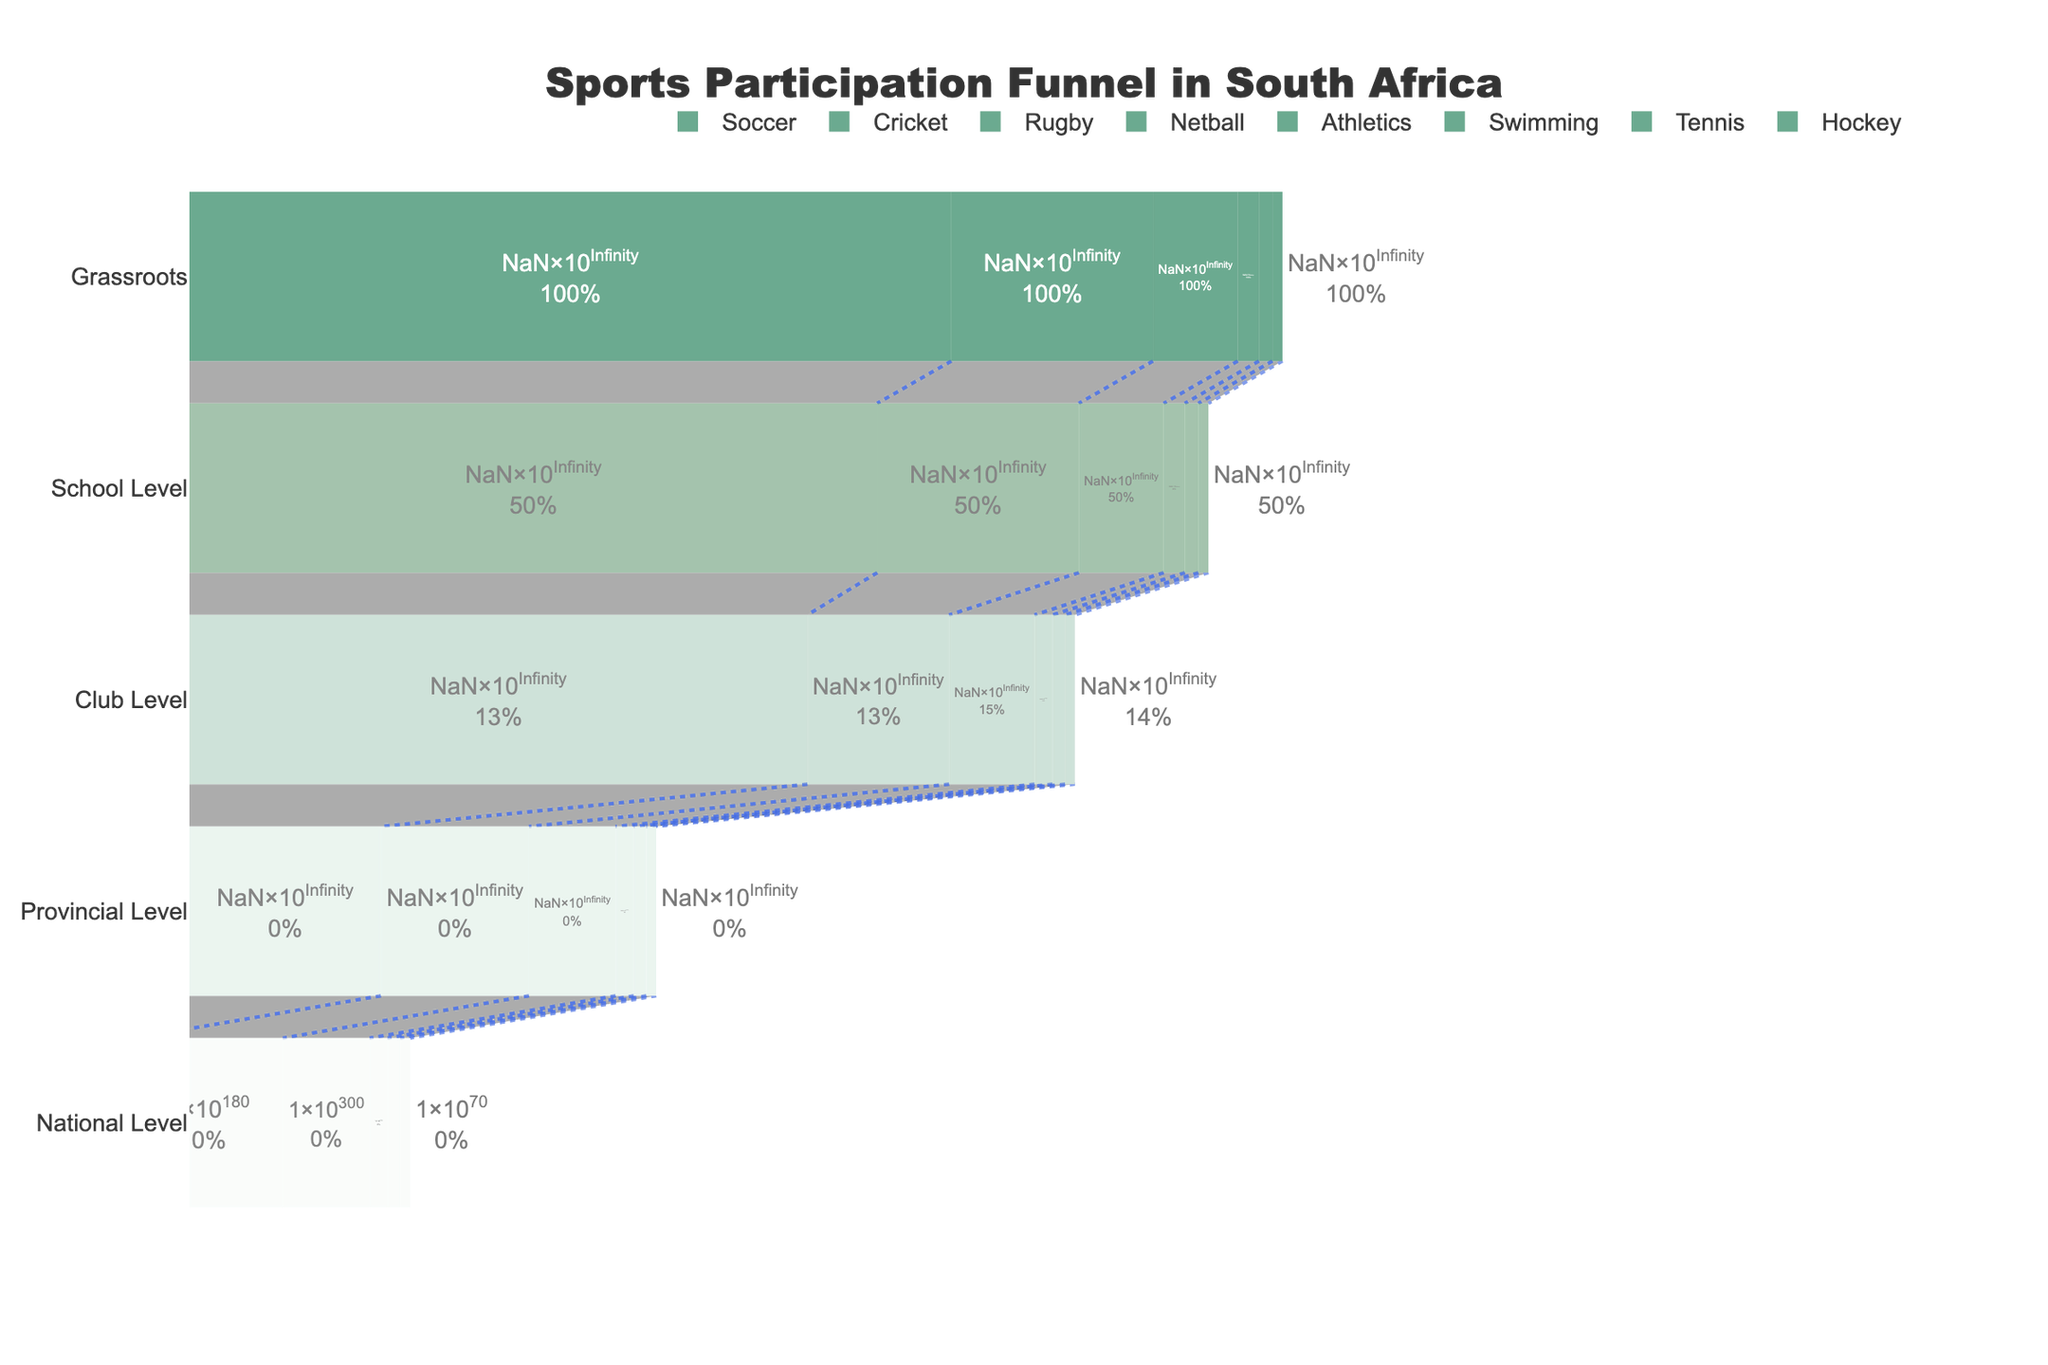What sport has the highest grassroots participation? At the grassroots level, the sport with the highest participation would be the one with the highest value in the "Grassroots" column. By referring to the chart, soccer has the highest value of 1,500,000 participants at the grassroots level.
Answer: Soccer Which sport has the least number of participants at the professional level? At the professional level, the sport with the least number of participants would have the lowest value in the "National Level" column. By referring to the chart, tennis has the lowest value of 80 participants at the national level.
Answer: Tennis How many participants drop from school level to club level in athletics? To determine how many participants drop, subtract the number of participants in the "Club Level" from the "School Level" for athletics. In the chart, school-level participation in athletics is 500,000, and club-level participation is 150,000. The drop is 500,000 - 150,000 = 350,000.
Answer: 350,000 What is the total number of participants at the provincial level across all sports? To find the total number of participants at the provincial level across all sports, sum the values in the "Provincial Level" column. By adding up all values: 5,000 + 2,000 + 1,500 + 1,800 + 3,000 + 1,000 + 800 + 700 = 15,800.
Answer: 15,800 Which sport shows the largest percentage drop from grassroots to school level? To determine the largest percentage drop from grassroots to school level, calculate the percentage drop for each sport and compare. Percentage drop = ((Grassroots - School Level) / Grassroots) * 100. For each sport:
Soccer: ((1,500,000 - 750,000) / 1,500,000) * 100 = 50%
Cricket: ((800,000 - 400,000) / 800,000) * 100 = 50%
Rugby: ((600,000 - 300,000) / 600,000) * 100 = 50%
Netball: ((700,000 - 350,000) / 700,000) * 100 = 50%
Athletics: ((1,000,000 - 500,000) / 1,000,000) * 100 = 50%
Swimming: ((400,000 - 200,000) / 400,000) * 100 = 50%
Tennis: ((300,000 - 150,000) / 300,000) * 100 = 50%
Hockey: ((250,000 - 125,000) / 250,000) * 100 = 50%. All sports have a 50% drop.
Answer: All sports (50%) Which sport has a higher number of participants at the national level: swimming or hockey? To determine which sport has a higher number at the national level, compare the 'National Level' values for swimming and hockey. The value is 100 for swimming and 70 for hockey.
Answer: Swimming Compare the total number of participants from grassroots to club level in rugby and netball. Which sport has more participants overall? Calculate the total by summing the values for Grassroots, School Level, and Club Level for both sports. Rugby: 600,000 (grassroots) + 300,000 (school) + 80,000 (club) = 980,000. Netball: 700,000 (grassroots) + 350,000 (school) + 90,000 (club) = 1,140,000. Netball has more participants overall.
Answer: Netball Which level shows the most significant decrease in participants for cricket? Identify where the largest participant drop is by comparing the differences between successive levels for cricket. The differences are:
Grassroots to School Level: 800,000 - 400,000 = 400,000
School Level to Club Level: 400,000 - 100,000 = 300,000
Club Level to Provincial Level: 100,000 - 2,000 = 98,000
Provincial Level to National Level: 2,000 - 200 = 1,800. The most significant decrease is from Grassroots to School Level.
Answer: Grassroots to School Level How does tennis participation at the school level compare to hockey at the club level? Compare the values at the respective levels. Tennis at the school level has 150,000 participants while hockey at the club level has 35,000 participants. Tennis has more participants at the school level than hockey at the club level.
Answer: Tennis What percentage of participants continue from provincial to national level in netball? Calculate the percentage by dividing the 'National Level' value by the 'Provincial Level' value and multiplying by 100. For netball: (180 / 1,800) * 100 = 10%.
Answer: 10% 